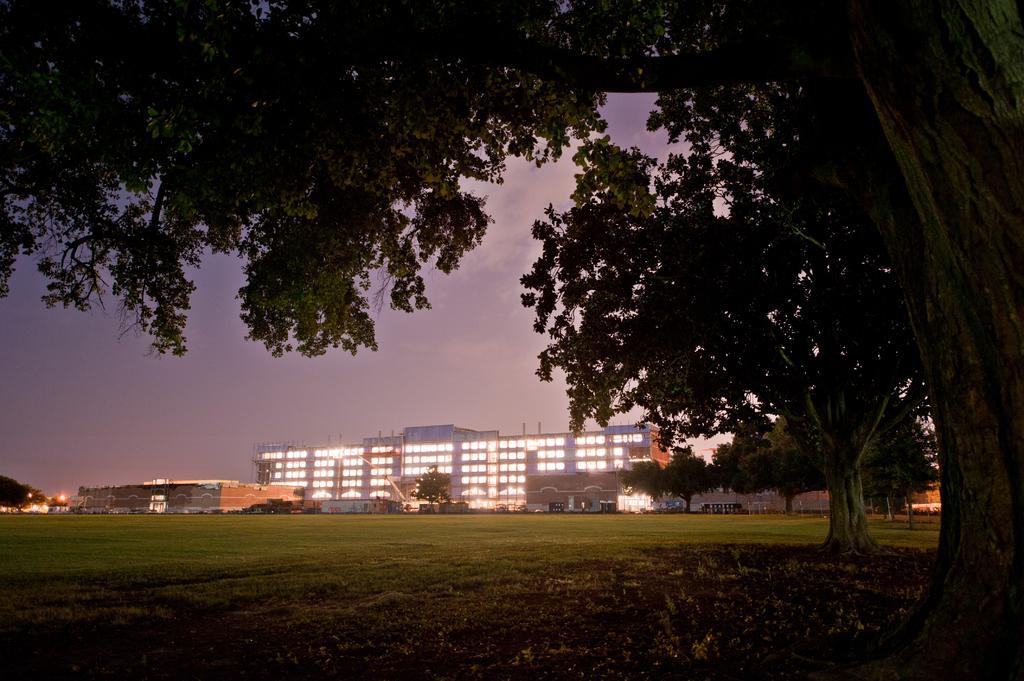In one or two sentences, can you explain what this image depicts? In this image there is a grassland, in the background there are buildings and the sky, on the right side there are trees. 